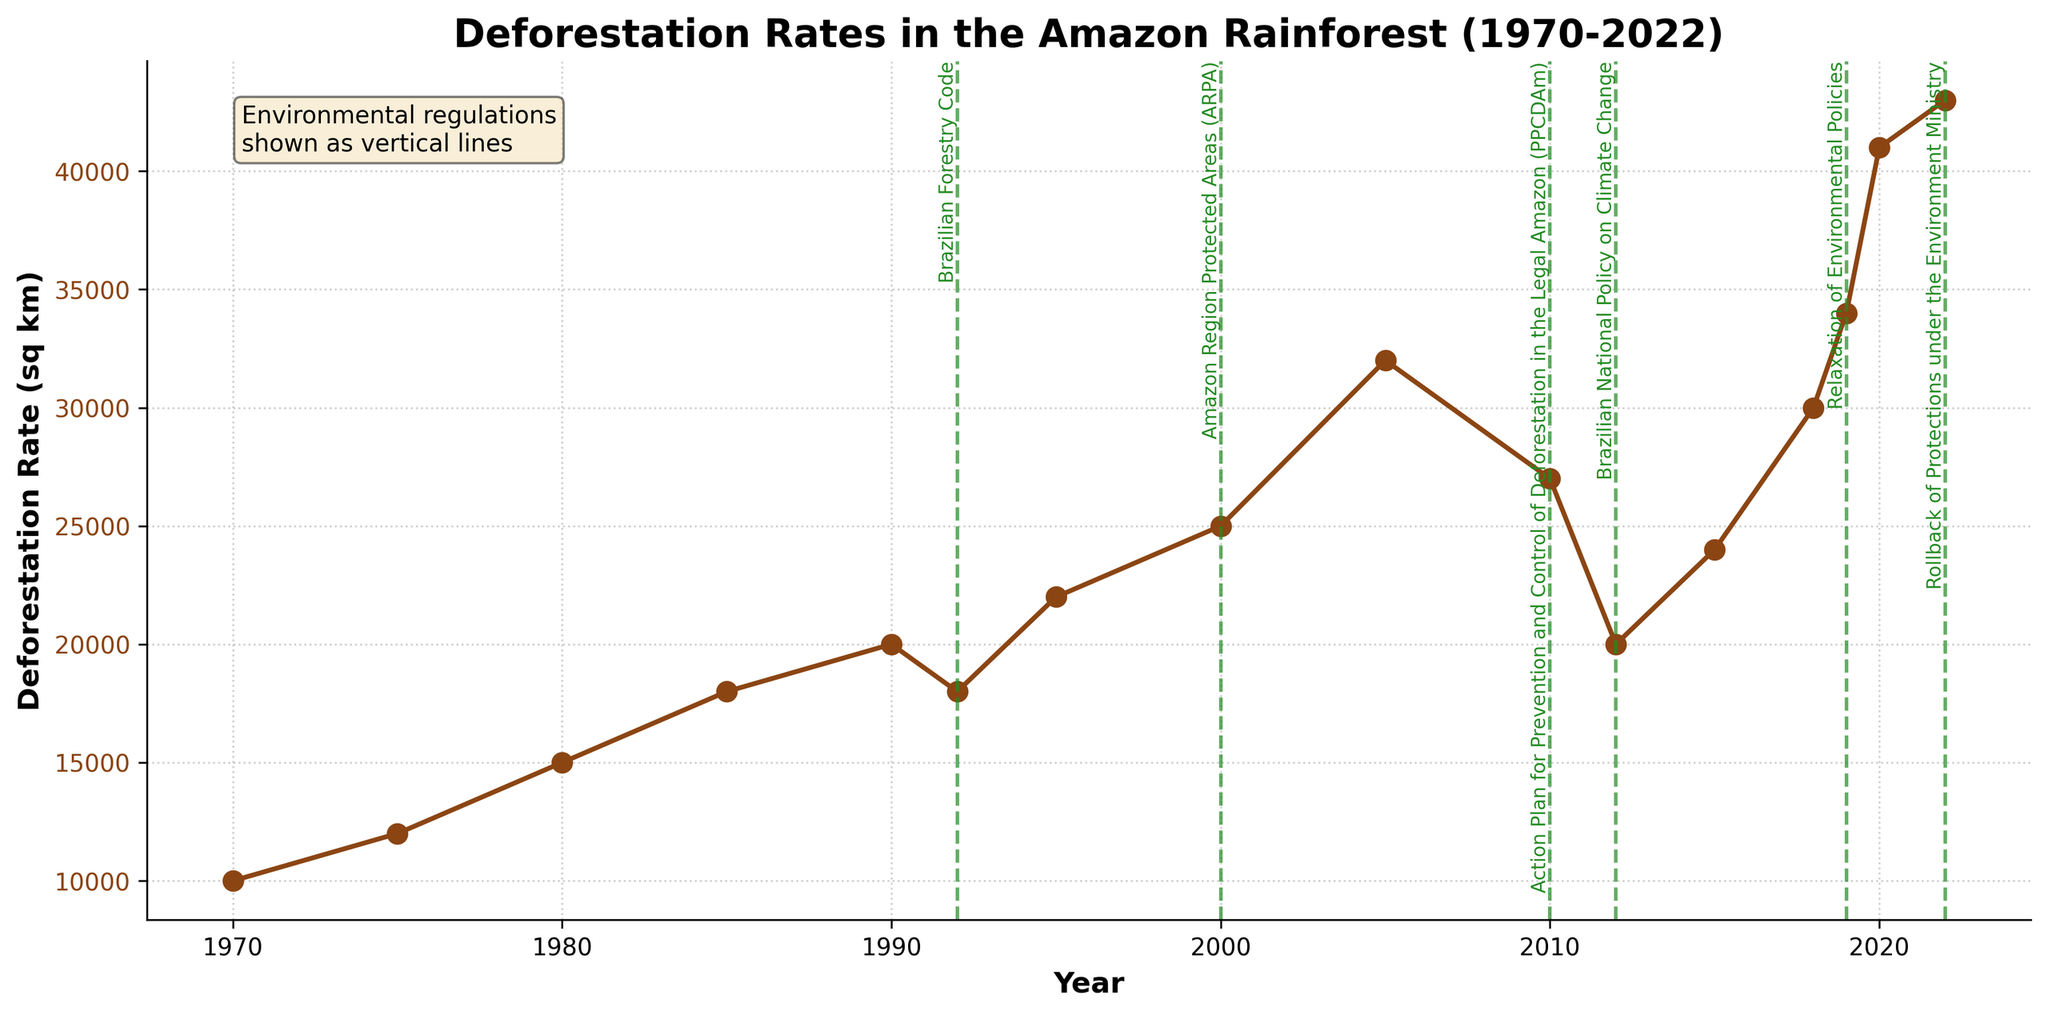What is the title of the figure? The title of a figure is typically displayed at the top, summarizing the main subject of the plot. In this case, it is "Deforestation Rates in the Amazon Rainforest (1970-2022)" as indicated in the code.
Answer: Deforestation Rates in the Amazon Rainforest (1970-2022) How many environmental regulations are shown on the plot? Environmental regulations are indicated as vertical lines with corresponding labels. There are regulations marked in the years 1992, 2000, 2010, 2012, 2019, and 2022.
Answer: 6 What is the general trend of deforestation rates from 1970 to 2022? By observing the plot, the deforestation rates generally increase over time from 1970 to 2022 with some fluctuations during certain periods. The line starts at 10,000 sq km in 1970 and reaches 43,000 sq km in 2022.
Answer: Increasing Between which years did the deforestation rate see the highest increase? By checking the steepest climb on the plot, between 2018 and 2020, deforestation rates jumped from 30,000 sq km to 41,000 sq km.
Answer: 2018 to 2020 What was the deforestation rate in 1992, the year when the Brazilian Forestry Code was introduced? Looking at the plot, the deforestation rate in 1992 is marked at 18,000 sq km.
Answer: 18,000 sq km Compare the deforestation rates before and after the introduction of the Action Plan for Prevention and Control of Deforestation in the Legal Amazon (PPCDAm) in 2010. The deforestation rate in 2010 was 27,000 sq km, and in 2012, following the introduction of PPCDAm, the rate dropped to 20,000 sq km.
Answer: Before: 27,000 sq km, After: 20,000 sq km By how many square kilometers did deforestation reduce between 2005 and 2012? Subtract the deforestation rate in 2012 (20,000 sq km) from the rate in 2005 (32,000 sq km). The decline is 32,000 sq km - 20,000 sq km = 12,000 sq km.
Answer: 12,000 sq km Which year had the highest recorded deforestation rate, and what was it? The highest point on the plot corresponds to the year 2022, with a deforestation rate of 43,000 sq km.
Answer: 2022, 43,000 sq km How does the deforestation rate in 2000 compare to that in 2015? The plot shows that in 2000 the deforestation rate was 25,000 sq km, while in 2015 it was 24,000 sq km.
Answer: 2000 was higher by 1,000 sq km 